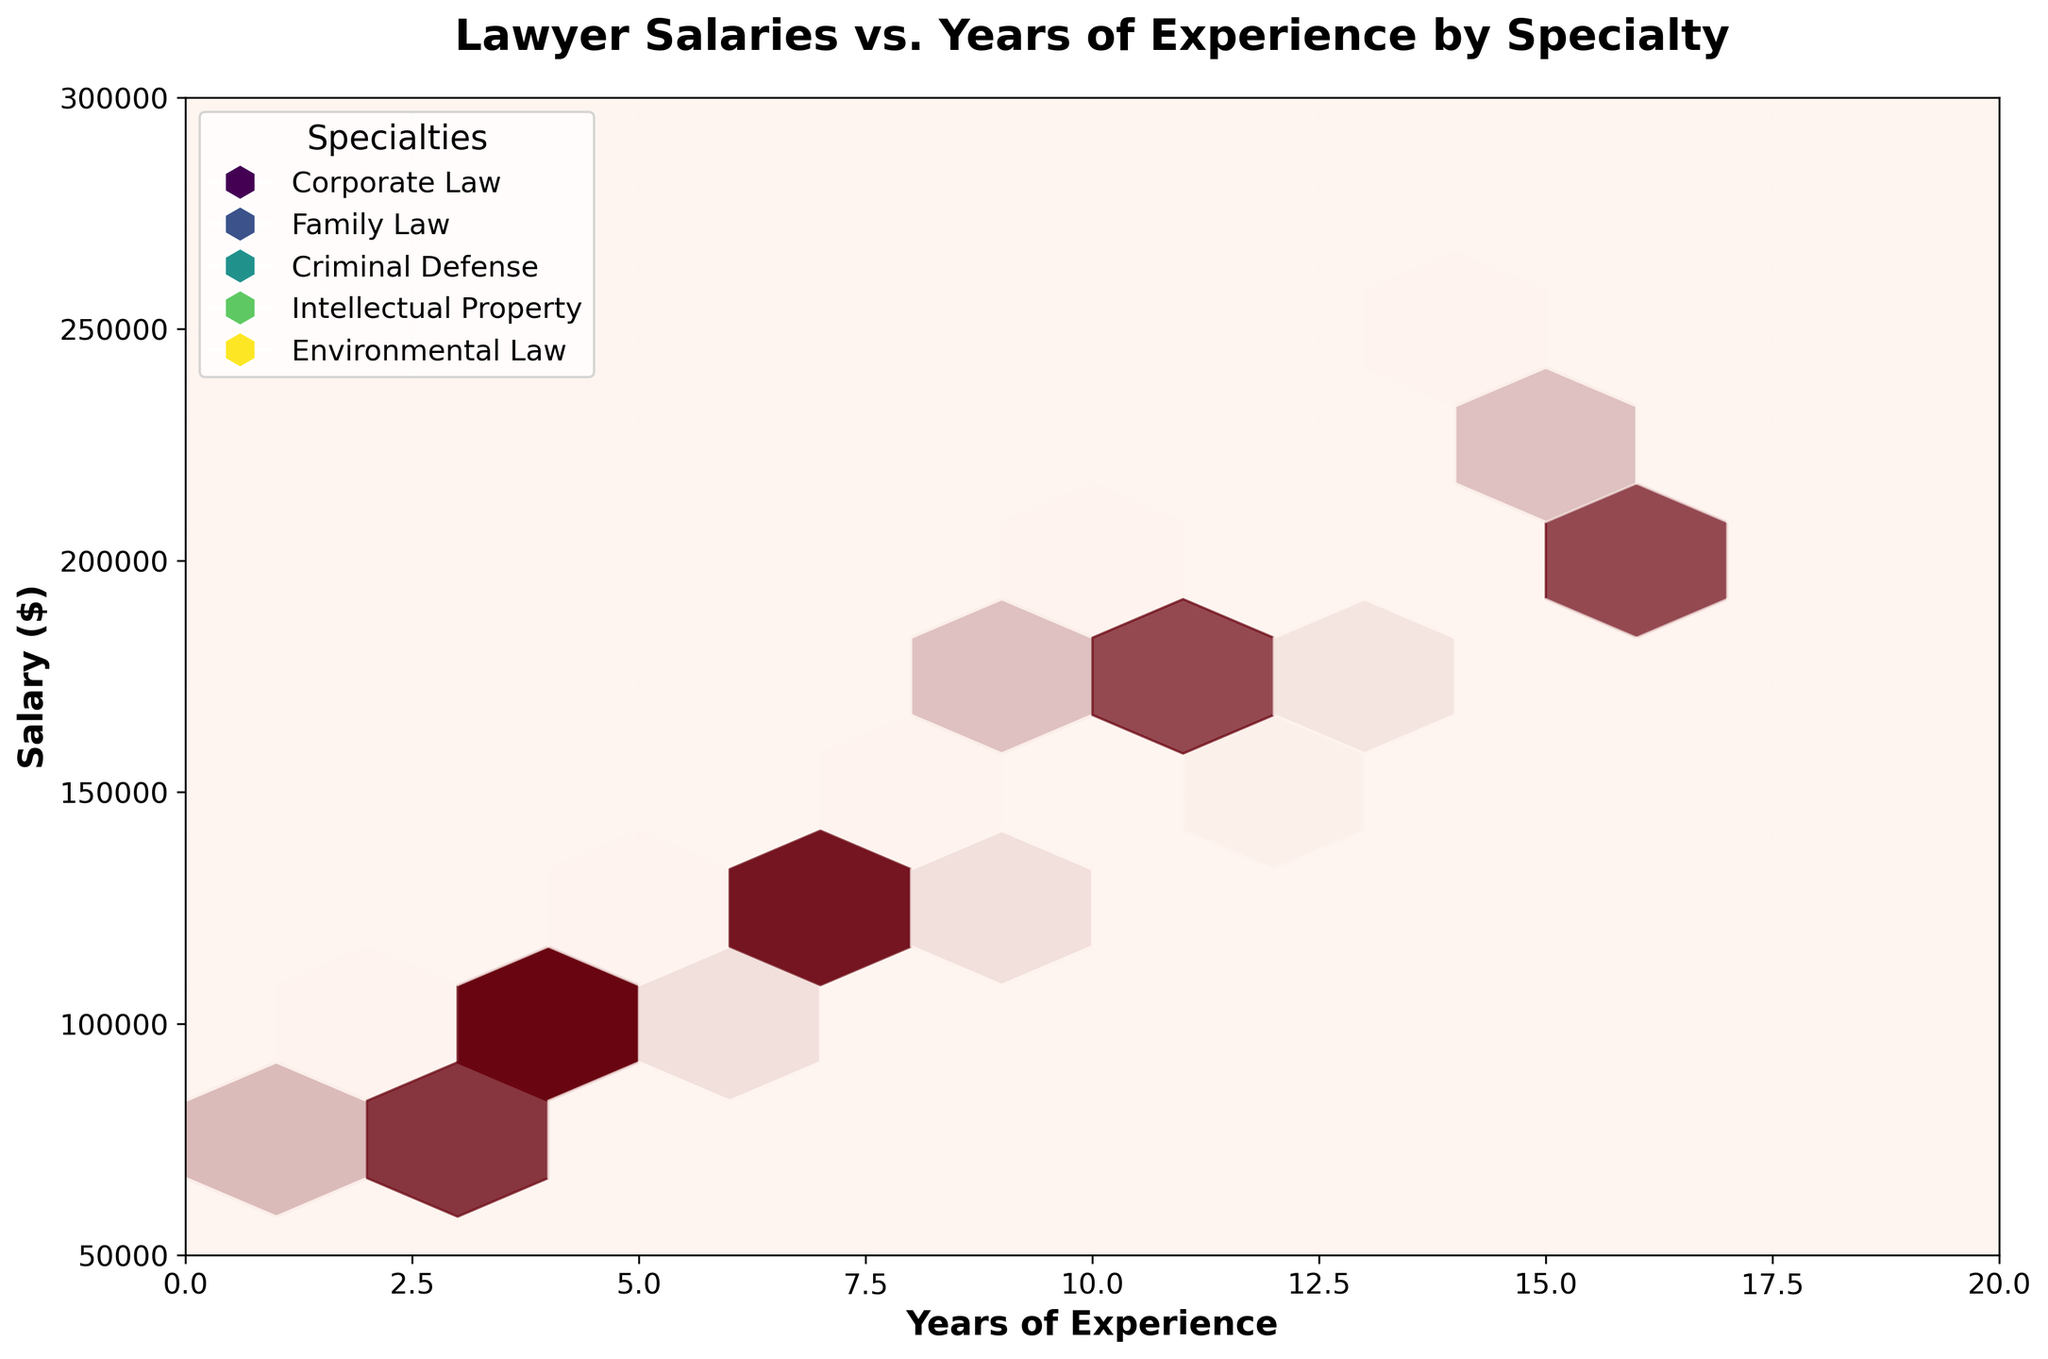What is the title of the plot? The title of the plot is typically found at the top of the figure. It provides a summary of what the figure represents.
Answer: Lawyer Salaries vs. Years of Experience by Specialty What are the units on the y-axis? The y-axis represents the salary of lawyers with a specified label. By observing the y-axis, it is marked in dollars.
Answer: Salary ($) What is the range of years of experience shown on the x-axis? The x-axis depicts the range of experience in years. Observing the axis labels, we see it ranges from 0 to 20 years.
Answer: 0 to 20 Which specialty shows the greatest maximum salary and what is the value? By examining the salary hexagons and their extent along the y-axis for each specialty, Intellectual Property shows the highest salary, reaching up to 240,000 dollars.
Answer: Intellectual Property, 240,000 How does the salary for Environmental Law at 16 years of experience compare to Corporate Law at the same experience level? By comparing the height of the hexagons for Environmental Law and Corporate Law around the 16-year mark on the x-axis, Environmental Law's salary is about 210,000 dollars, whereas Corporate Law does not reach this experience level.
Answer: Environmental Law is higher What is the median salary for Criminal Defense between 2 and 14 years of experience? To find the median, we need to look at the salaries plotted for Criminal Defense between the years 2 and 14. The values are 70,000, 90,000, 110,000, 140,000, and 180,000 dollars. The median in this series is the middle value, 110,000 dollars.
Answer: 110,000 How does the salary trend for Family Law compare with Corporate Law over the first 10 years? Compare hexagon heights along the x-axis up to the 10-year mark for both specialties. Corporate Law shows a steeper salary increase, starting at 75,000 dollars and reaching 200,000 dollars, whereas Family Law starts at 65,000 dollars and reaches around 160,000 dollars.
Answer: Corporate Law increases faster Which specialty shows the highest starting salary, and what is the value? The starting salary is found at the 1-year mark on the x-axis. By comparing the heights of the hexagons, Intellectual Property shows the highest starting salary of 80,000 dollars.
Answer: Intellectual Property, 80,000 What specialty has the most consistent increase in salary with years of experience? Consistency implies a steady upward trend. Observing hexagon placement relative to the x-axis, Corporate Law shows the most consistent increase as its salary rises steadily with experience.
Answer: Corporate Law How does the salary for 10 years of experience in Family Law compare to 10 years in Intellectual Property? Comparing the hexagons at the 10-year mark for both specialties, Family Law shows about 160,000 dollars, whereas Intellectual Property shows about 180,000 dollars.
Answer: Intellectual Property is higher 